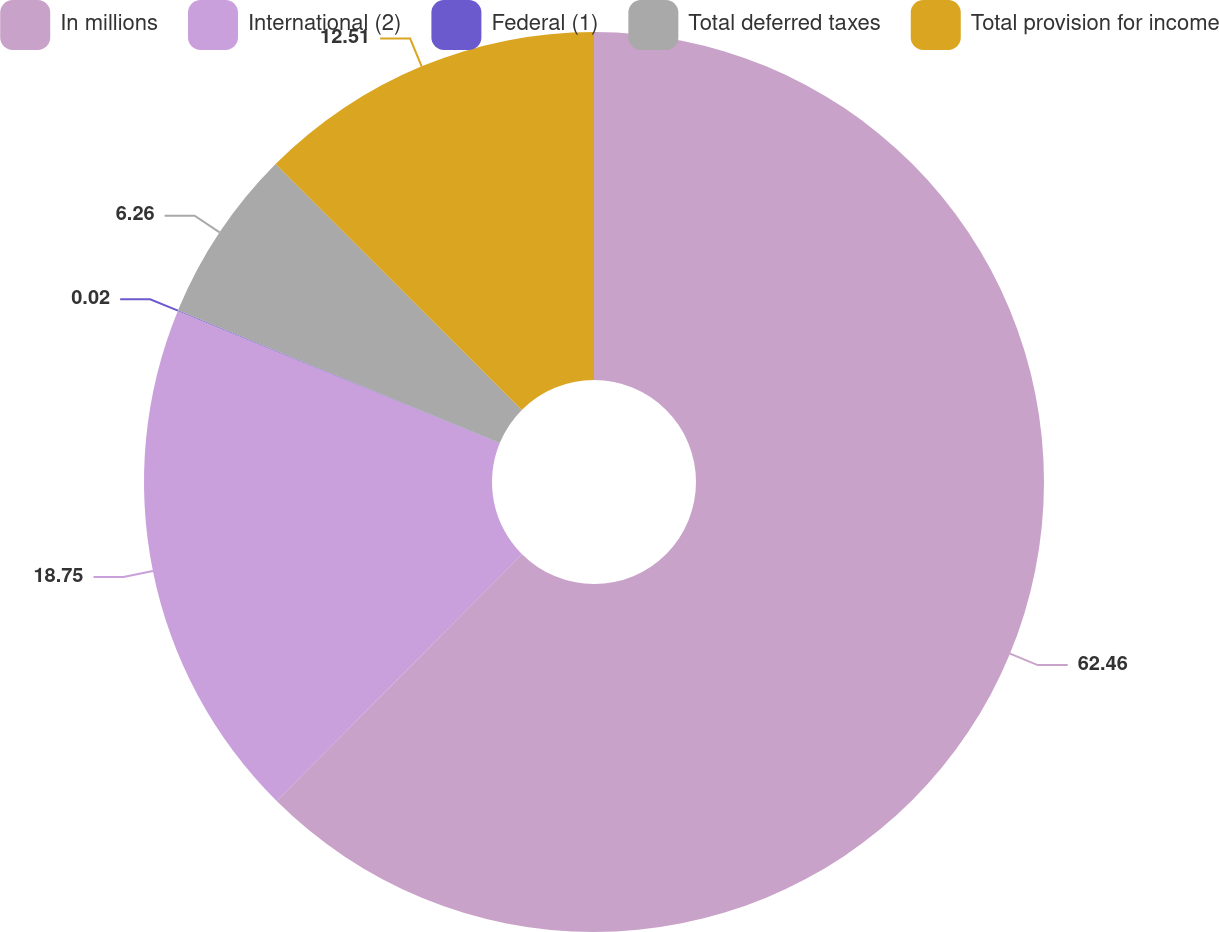<chart> <loc_0><loc_0><loc_500><loc_500><pie_chart><fcel>In millions<fcel>International (2)<fcel>Federal (1)<fcel>Total deferred taxes<fcel>Total provision for income<nl><fcel>62.45%<fcel>18.75%<fcel>0.02%<fcel>6.26%<fcel>12.51%<nl></chart> 